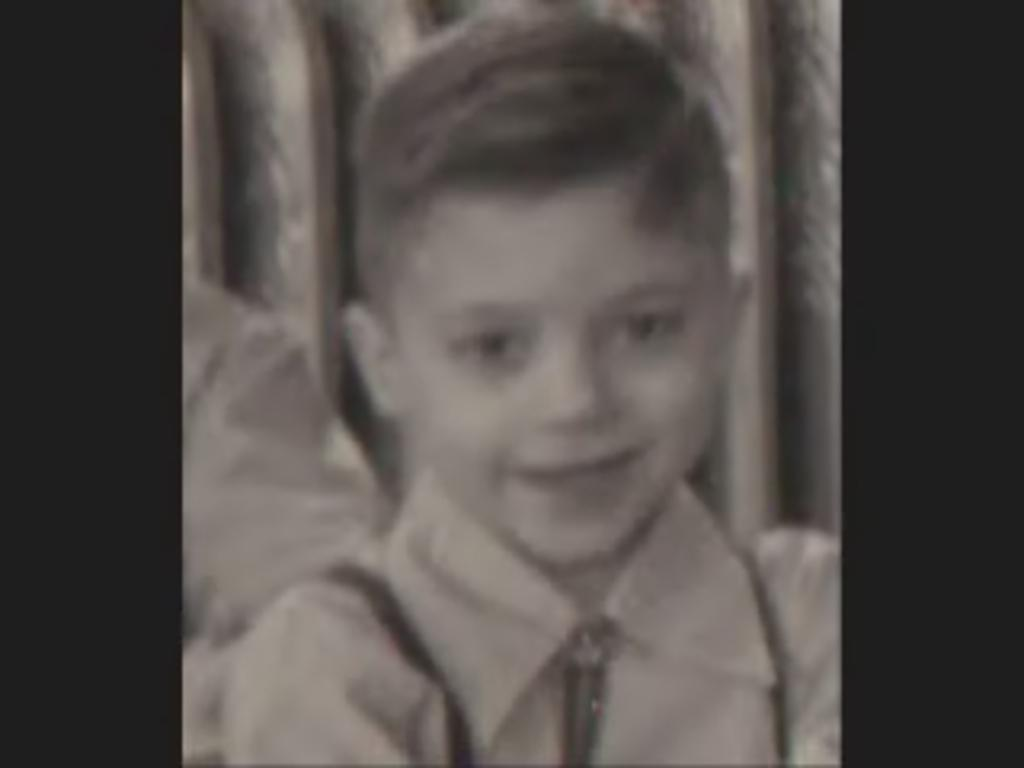What is the main subject of the image? There is a photo of a boy in the image. What can be observed about the background of the image? The background of the image is dark. What is the name of the volleyball player in the image? There is no volleyball player present in the image; it features a photo of a boy. What class is the boy in the image attending? There is no information about the boy's class in the image. 